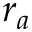Convert formula to latex. <formula><loc_0><loc_0><loc_500><loc_500>r _ { a }</formula> 